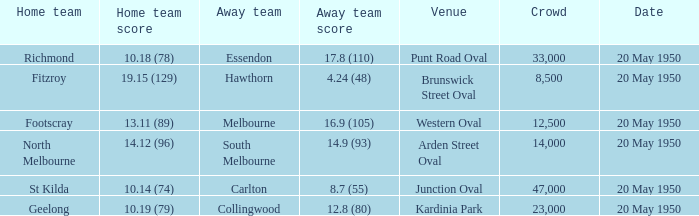What was the largest crowd to view a game where the away team scored 17.8 (110)? 33000.0. Parse the full table. {'header': ['Home team', 'Home team score', 'Away team', 'Away team score', 'Venue', 'Crowd', 'Date'], 'rows': [['Richmond', '10.18 (78)', 'Essendon', '17.8 (110)', 'Punt Road Oval', '33,000', '20 May 1950'], ['Fitzroy', '19.15 (129)', 'Hawthorn', '4.24 (48)', 'Brunswick Street Oval', '8,500', '20 May 1950'], ['Footscray', '13.11 (89)', 'Melbourne', '16.9 (105)', 'Western Oval', '12,500', '20 May 1950'], ['North Melbourne', '14.12 (96)', 'South Melbourne', '14.9 (93)', 'Arden Street Oval', '14,000', '20 May 1950'], ['St Kilda', '10.14 (74)', 'Carlton', '8.7 (55)', 'Junction Oval', '47,000', '20 May 1950'], ['Geelong', '10.19 (79)', 'Collingwood', '12.8 (80)', 'Kardinia Park', '23,000', '20 May 1950']]} 